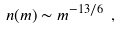Convert formula to latex. <formula><loc_0><loc_0><loc_500><loc_500>n ( m ) \sim m ^ { - 1 3 / 6 } \ ,</formula> 